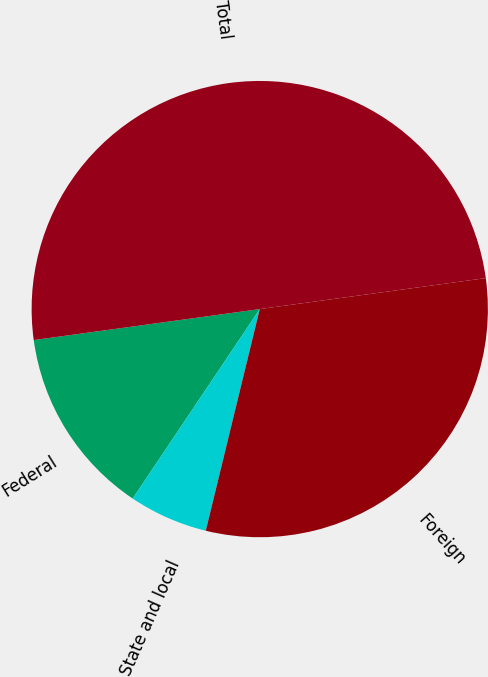Convert chart. <chart><loc_0><loc_0><loc_500><loc_500><pie_chart><fcel>Federal<fcel>State and local<fcel>Foreign<fcel>Total<nl><fcel>13.43%<fcel>5.6%<fcel>30.97%<fcel>50.0%<nl></chart> 